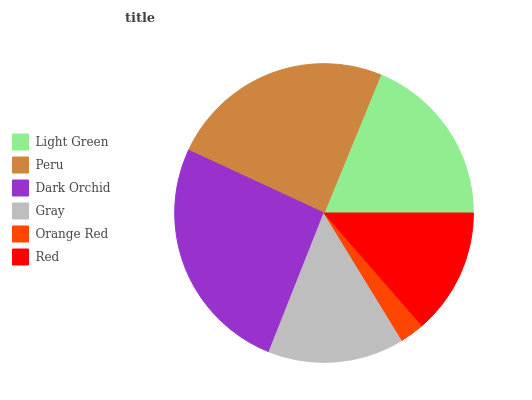Is Orange Red the minimum?
Answer yes or no. Yes. Is Dark Orchid the maximum?
Answer yes or no. Yes. Is Peru the minimum?
Answer yes or no. No. Is Peru the maximum?
Answer yes or no. No. Is Peru greater than Light Green?
Answer yes or no. Yes. Is Light Green less than Peru?
Answer yes or no. Yes. Is Light Green greater than Peru?
Answer yes or no. No. Is Peru less than Light Green?
Answer yes or no. No. Is Light Green the high median?
Answer yes or no. Yes. Is Gray the low median?
Answer yes or no. Yes. Is Gray the high median?
Answer yes or no. No. Is Red the low median?
Answer yes or no. No. 